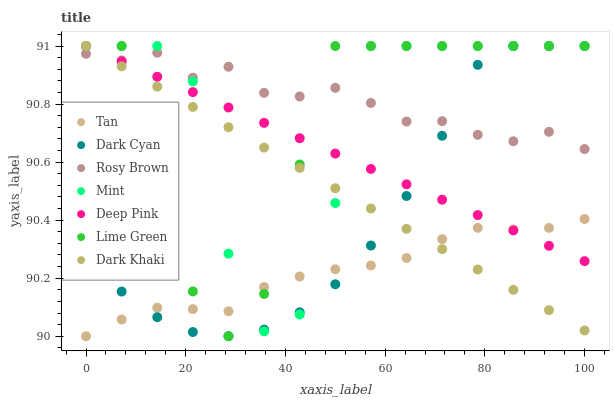Does Tan have the minimum area under the curve?
Answer yes or no. Yes. Does Rosy Brown have the maximum area under the curve?
Answer yes or no. Yes. Does Mint have the minimum area under the curve?
Answer yes or no. No. Does Mint have the maximum area under the curve?
Answer yes or no. No. Is Dark Khaki the smoothest?
Answer yes or no. Yes. Is Mint the roughest?
Answer yes or no. Yes. Is Rosy Brown the smoothest?
Answer yes or no. No. Is Rosy Brown the roughest?
Answer yes or no. No. Does Tan have the lowest value?
Answer yes or no. Yes. Does Mint have the lowest value?
Answer yes or no. No. Does Lime Green have the highest value?
Answer yes or no. Yes. Does Rosy Brown have the highest value?
Answer yes or no. No. Is Tan less than Rosy Brown?
Answer yes or no. Yes. Is Rosy Brown greater than Tan?
Answer yes or no. Yes. Does Mint intersect Deep Pink?
Answer yes or no. Yes. Is Mint less than Deep Pink?
Answer yes or no. No. Is Mint greater than Deep Pink?
Answer yes or no. No. Does Tan intersect Rosy Brown?
Answer yes or no. No. 